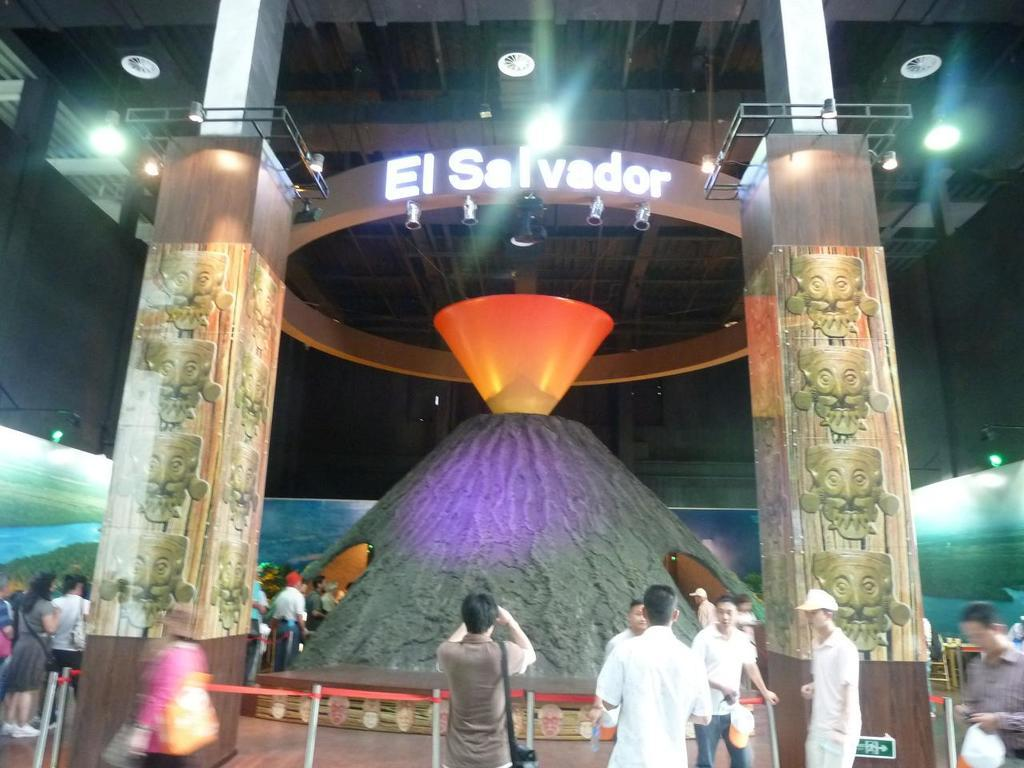What is the main setting of the image? The main setting of the image is a museum. What can be seen in the middle of the image? There is a hill in the middle of the image. What is the source of illumination in the image? Lights are visible over the ceiling. What type of branch can be seen growing from the hill in the image? There is no branch growing from the hill in the image; it is a hill inside a museum. 